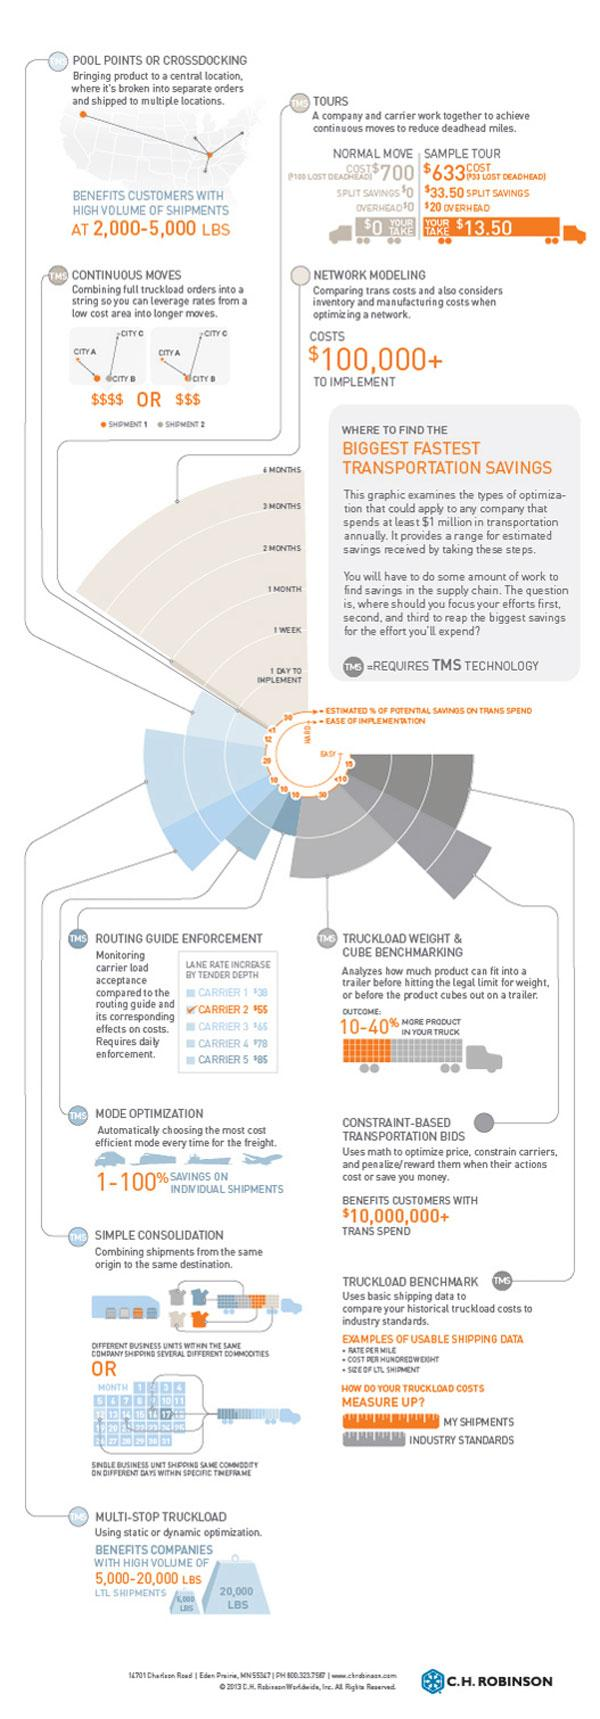Specify some key components in this picture. Continuous Moves is the method of shipping that utilizes cities with lower costs to reduce shipping expenses. This method involves the movement of goods from one location to another without interruption, resulting in a more efficient and cost-effective shipping process. The transportation method that requires the highest cost of implementation is network modeling. In recent years, the implementation of TMS technology in various transportation methods has become increasingly common. In fact, many transportation methods, such as road freight, ocean freight, air freight, and rail freight, have begun to utilize TMS technology to streamline their operations and improve their efficiency. Therefore, it is accurate to say that TMS technology is widely used in various transportation methods. 